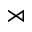Convert formula to latex. <formula><loc_0><loc_0><loc_500><loc_500>\rtimes</formula> 